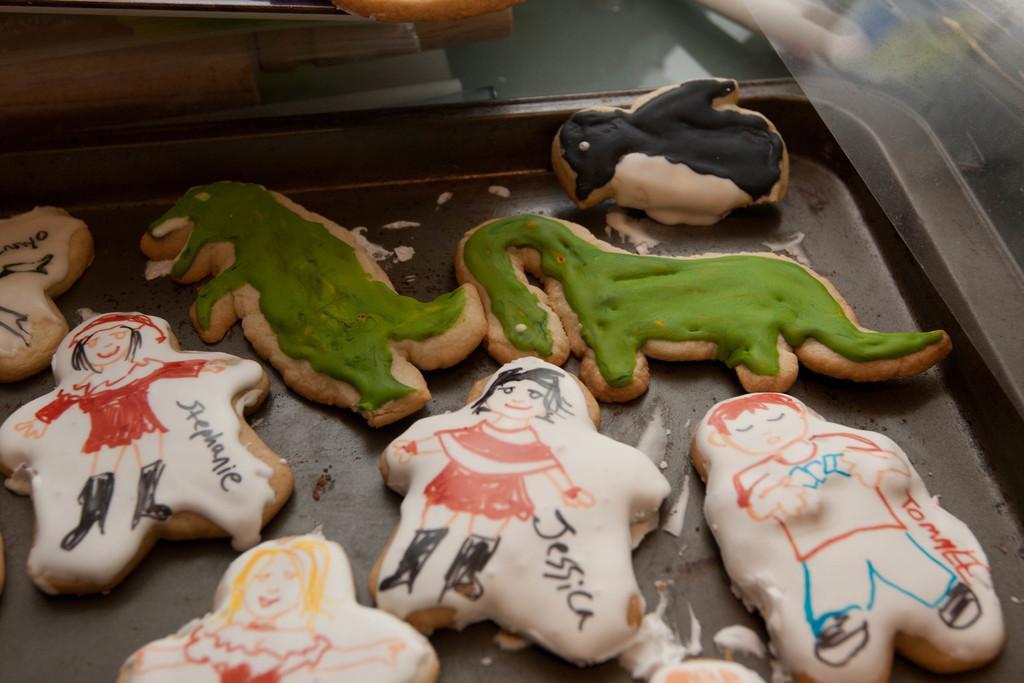Can you describe this image briefly? In the foreground of the picture there is a tray, in the tray there are cookies with different shapes. At the top there are knives and some objects. 